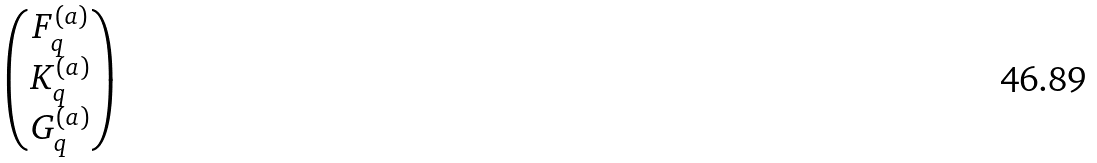Convert formula to latex. <formula><loc_0><loc_0><loc_500><loc_500>\begin{pmatrix} F ^ { ( a ) } _ { q } \\ K ^ { ( a ) } _ { q } \\ G ^ { ( a ) } _ { q } \end{pmatrix}</formula> 